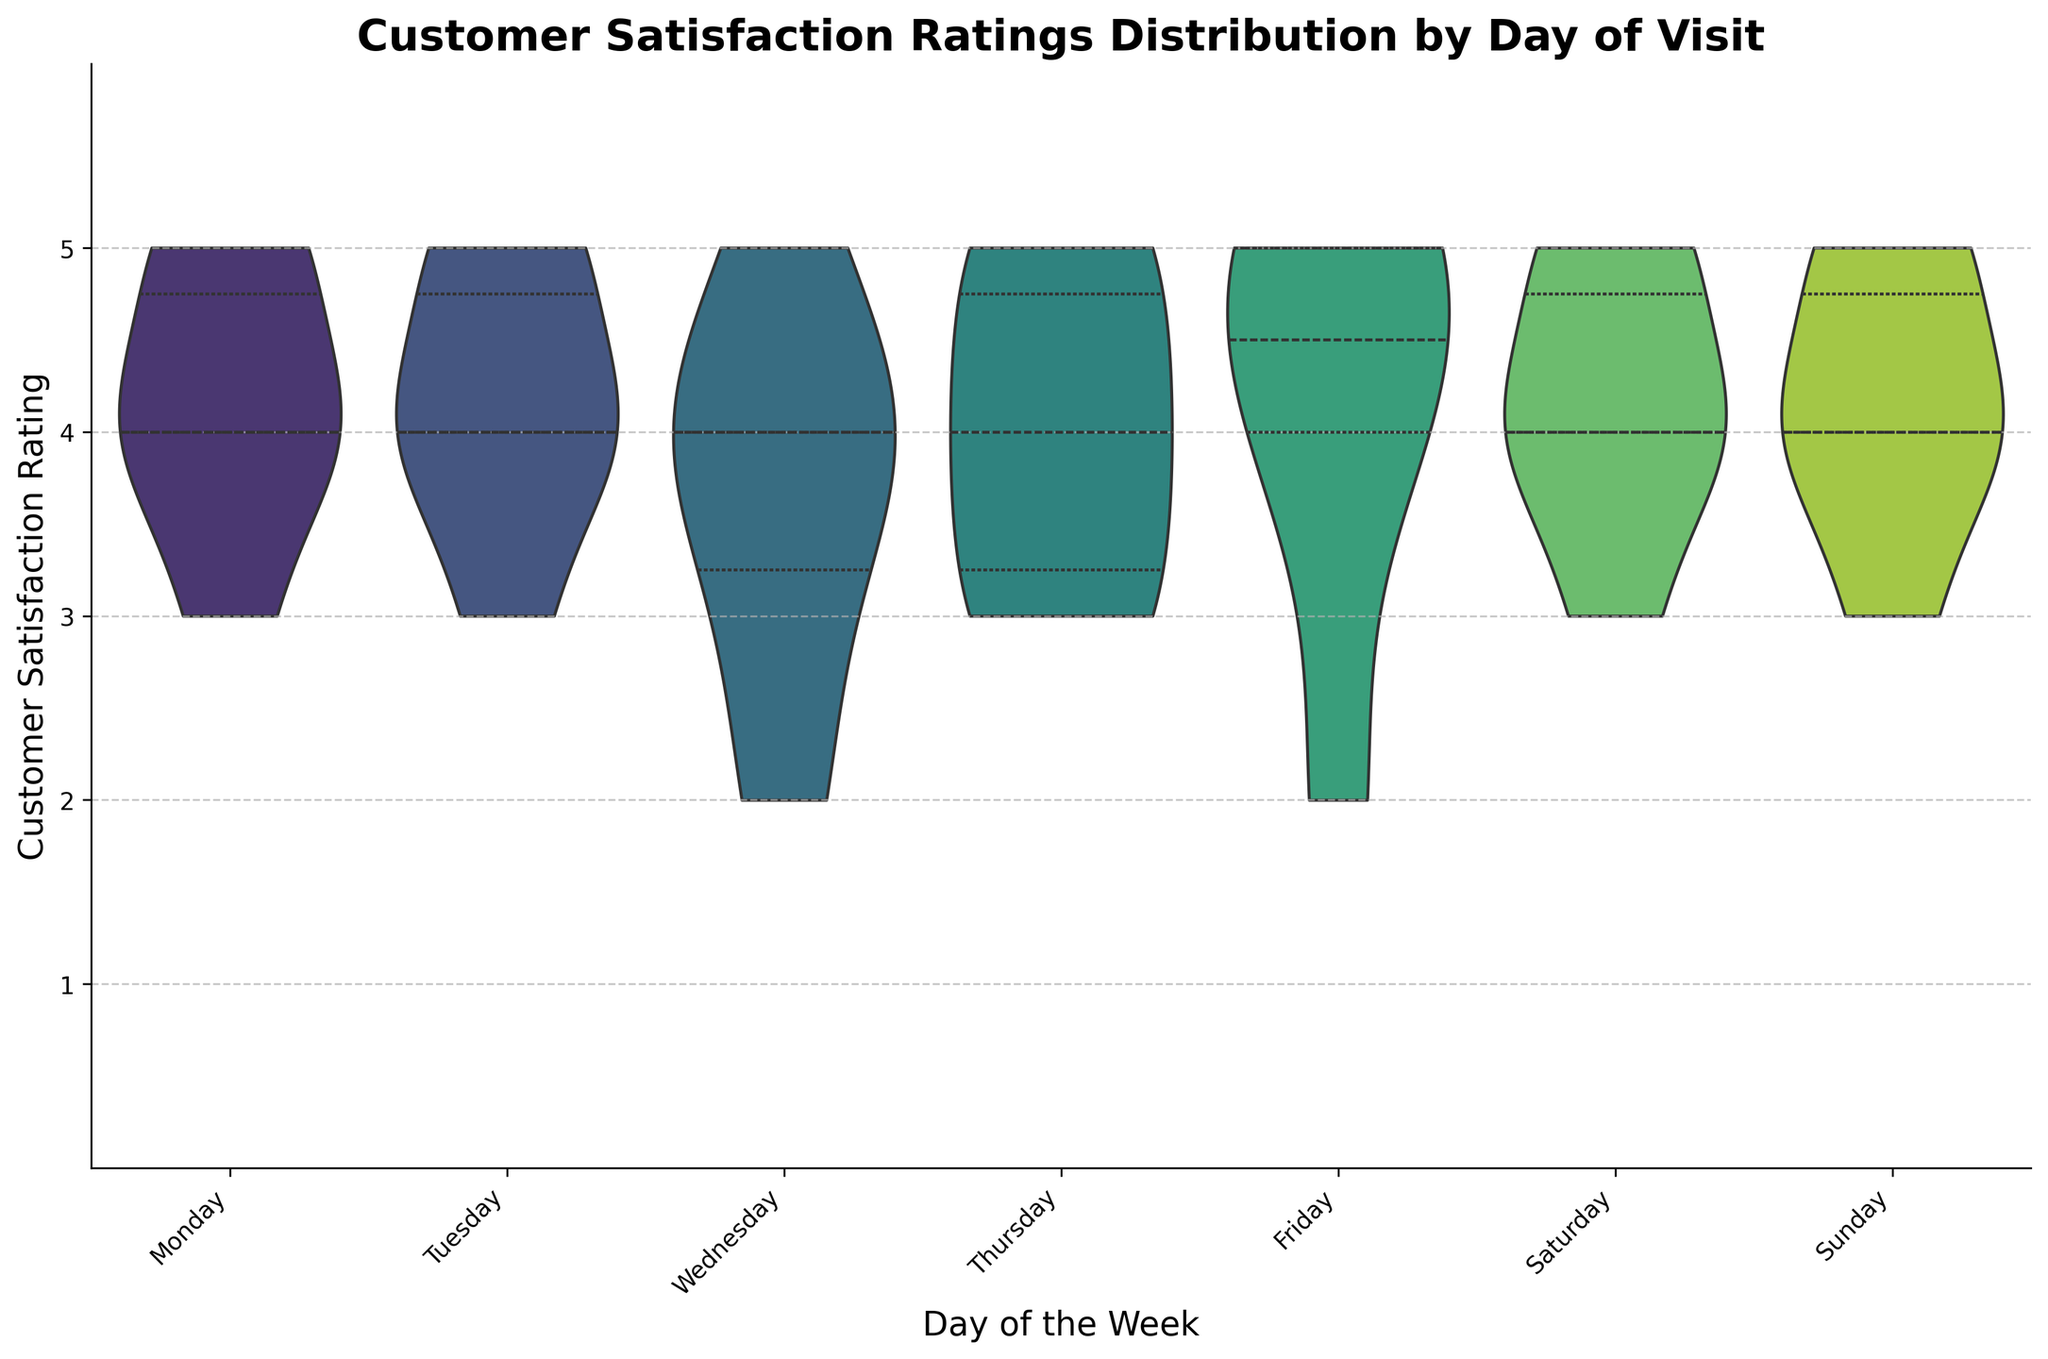What's the title of the figure? The title appears at the top of the figure and is typically set in a larger and bold font. The title gives an idea about the content of the figure.
Answer: Customer Satisfaction Ratings Distribution by Day of Visit On which day is the customer satisfaction rating most varied? Look for the day with the widest distribution on its corresponding violin plot. The wider the distribution, the more varied the ratings.
Answer: Wednesday What is the range of ratings for Friday? Examine the vertical span of the violin plot for Friday. The range is determined by the highest and lowest points where the plot extends.
Answer: 2 to 5 Which days have the highest median customer satisfaction ratings? The median is typically indicated by a central line within the violin plot. Identify the days where this central line is at the highest level.
Answer: Monday, Tuesday, Thursday, Friday, Saturday, Sunday Which day shows the narrowest distribution of customer satisfaction ratings? The narrowest distribution can be seen where the violin plot is thinnest. This indicates less variability in ratings.
Answer: Sunday How does the customer satisfaction on Monday compare to that on Wednesday? Compare the shapes and central tendencies (indicated by quartiles or central lines) of the violin plots for Monday and Wednesday. Note differences in spread and central tendency.
Answer: Monday is higher and less varied than Wednesday What is the most common rating value across all days? The most common rating is the mode, which corresponds to the widest part of the violin plots across all days.
Answer: 4 On which days do the customer satisfaction ratings include a 2? Examine the vertical extent of the violin plots for each day to see which ones reach down to a rating of 2.
Answer: Wednesday, Thursday, Friday Which day has the lowest median customer satisfaction rating? Identify the central quartile line within each violin plot to find the day where the median line is at its lowest position.
Answer: Wednesday Is there any day with a customer satisfaction rating of 1? Check the lower bounds of the violin plots to see if any extend down to the rating value of 1.
Answer: No 